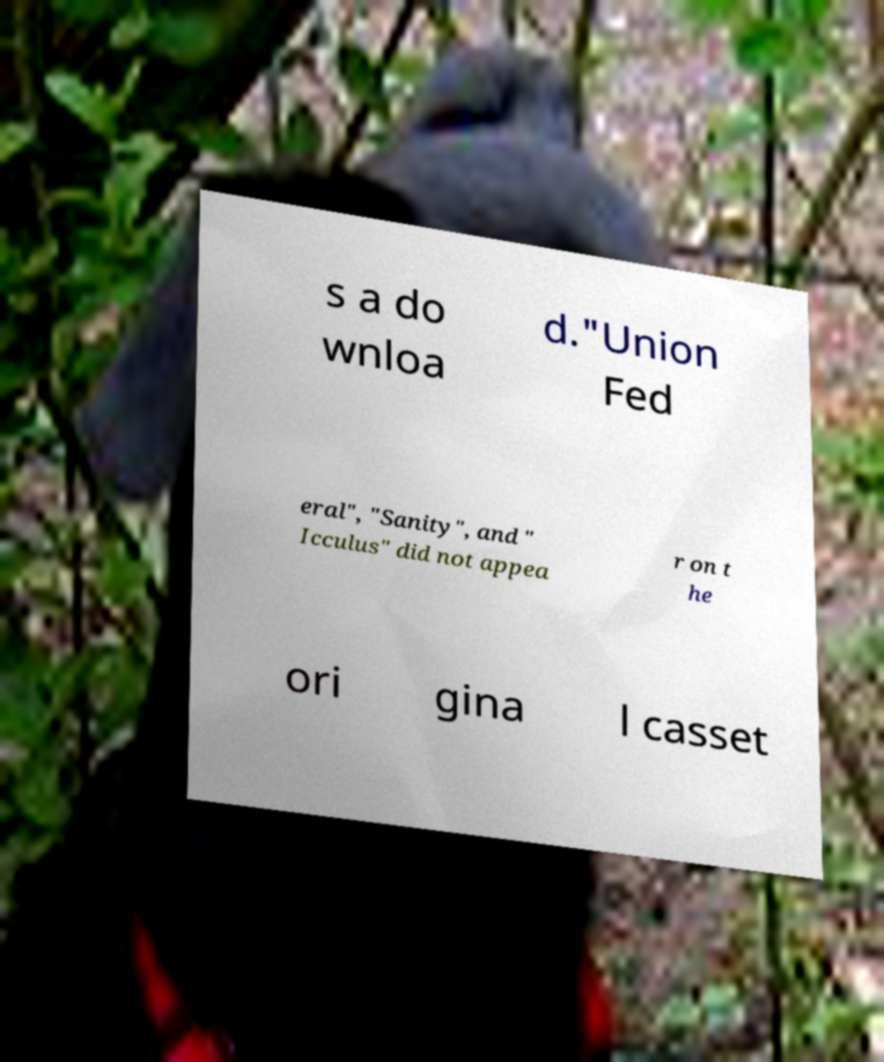Could you assist in decoding the text presented in this image and type it out clearly? s a do wnloa d."Union Fed eral", "Sanity", and " Icculus" did not appea r on t he ori gina l casset 